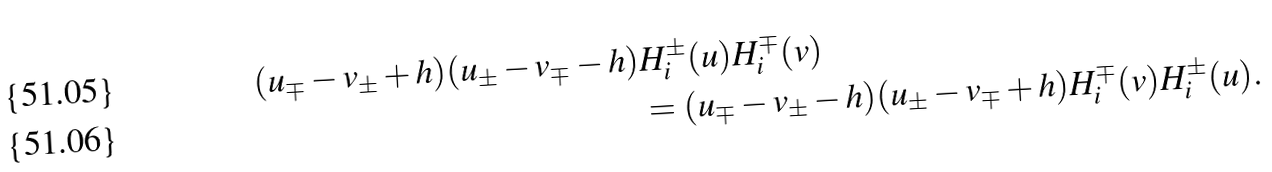Convert formula to latex. <formula><loc_0><loc_0><loc_500><loc_500>( u _ { \mp } - v _ { \pm } + h ) ( u _ { \pm } - v _ { \mp } - h ) & H _ { i } ^ { \pm } ( u ) H _ { i } ^ { \mp } ( v ) \\ & = ( u _ { \mp } - v _ { \pm } - h ) ( u _ { \pm } - v _ { \mp } + h ) H _ { i } ^ { \mp } ( v ) H _ { i } ^ { \pm } ( u ) .</formula> 